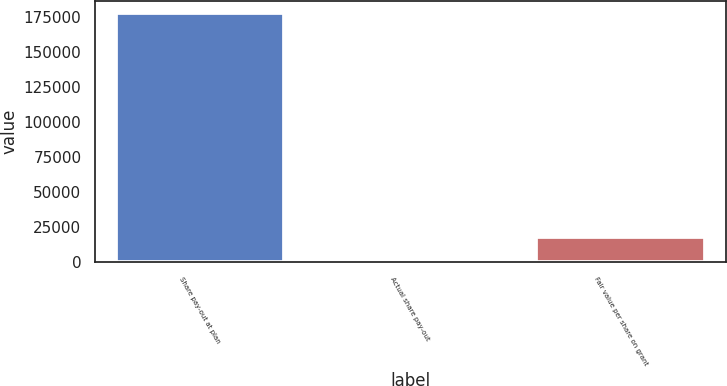<chart> <loc_0><loc_0><loc_500><loc_500><bar_chart><fcel>Share pay-out at plan<fcel>Actual share pay-out<fcel>Fair value per share on grant<nl><fcel>177680<fcel>4.58<fcel>17772.1<nl></chart> 